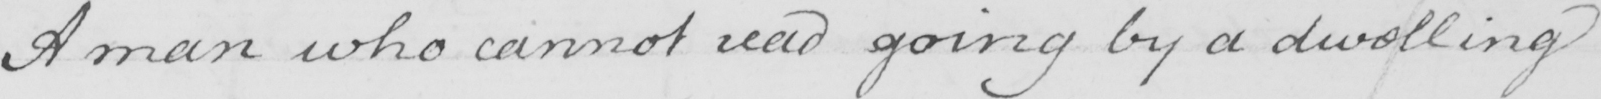What text is written in this handwritten line? A man who cannot read going by a dwelling 